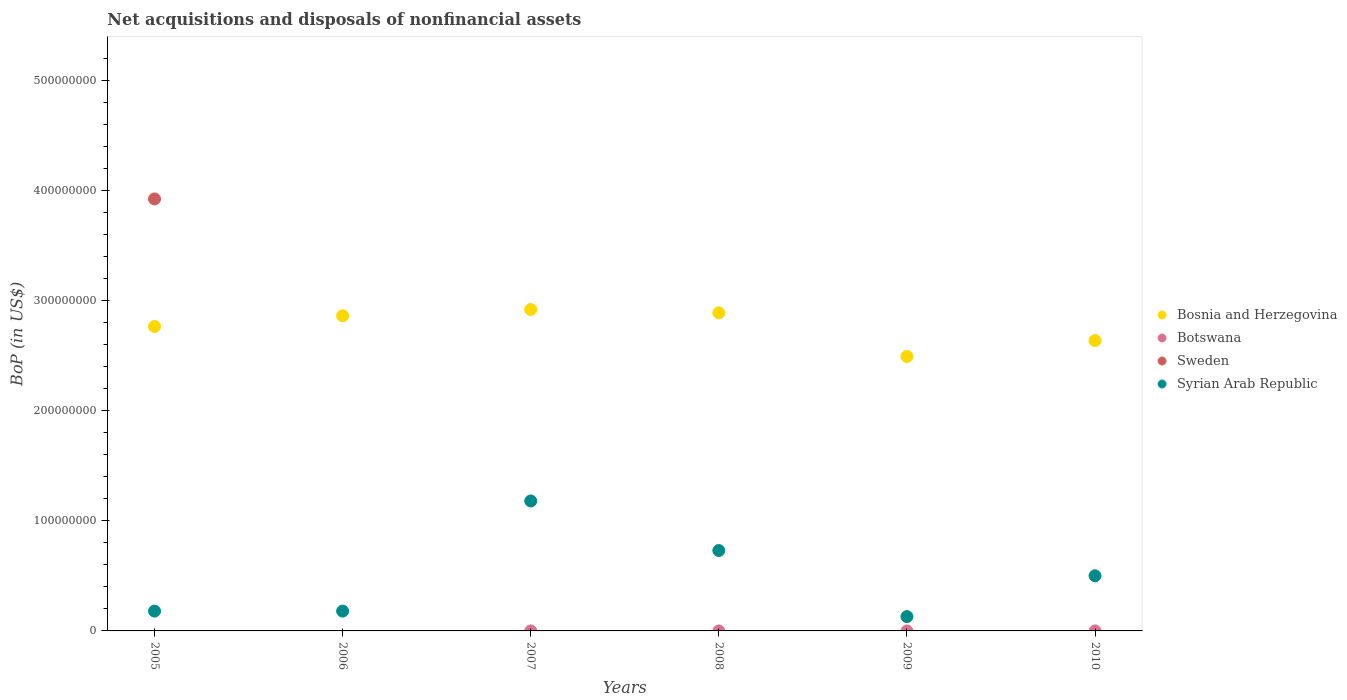How many different coloured dotlines are there?
Keep it short and to the point. 3. Across all years, what is the maximum Balance of Payments in Bosnia and Herzegovina?
Your response must be concise. 2.92e+08. In which year was the Balance of Payments in Syrian Arab Republic maximum?
Keep it short and to the point. 2007. What is the total Balance of Payments in Bosnia and Herzegovina in the graph?
Your response must be concise. 1.66e+09. What is the difference between the Balance of Payments in Syrian Arab Republic in 2009 and that in 2010?
Keep it short and to the point. -3.71e+07. What is the difference between the Balance of Payments in Botswana in 2005 and the Balance of Payments in Bosnia and Herzegovina in 2009?
Ensure brevity in your answer.  -2.49e+08. In the year 2007, what is the difference between the Balance of Payments in Syrian Arab Republic and Balance of Payments in Bosnia and Herzegovina?
Offer a very short reply. -1.74e+08. What is the ratio of the Balance of Payments in Syrian Arab Republic in 2005 to that in 2007?
Make the answer very short. 0.15. Is the Balance of Payments in Syrian Arab Republic in 2005 less than that in 2007?
Your answer should be compact. Yes. What is the difference between the highest and the second highest Balance of Payments in Bosnia and Herzegovina?
Make the answer very short. 3.07e+06. What is the difference between the highest and the lowest Balance of Payments in Sweden?
Your answer should be compact. 3.92e+08. Is the sum of the Balance of Payments in Bosnia and Herzegovina in 2008 and 2010 greater than the maximum Balance of Payments in Syrian Arab Republic across all years?
Give a very brief answer. Yes. Is it the case that in every year, the sum of the Balance of Payments in Sweden and Balance of Payments in Botswana  is greater than the Balance of Payments in Bosnia and Herzegovina?
Give a very brief answer. No. Is the Balance of Payments in Botswana strictly less than the Balance of Payments in Bosnia and Herzegovina over the years?
Make the answer very short. Yes. How many dotlines are there?
Your answer should be compact. 3. How many years are there in the graph?
Your response must be concise. 6. What is the difference between two consecutive major ticks on the Y-axis?
Keep it short and to the point. 1.00e+08. Does the graph contain any zero values?
Your answer should be compact. Yes. Does the graph contain grids?
Your response must be concise. No. What is the title of the graph?
Provide a succinct answer. Net acquisitions and disposals of nonfinancial assets. Does "Cambodia" appear as one of the legend labels in the graph?
Your answer should be very brief. No. What is the label or title of the Y-axis?
Offer a terse response. BoP (in US$). What is the BoP (in US$) of Bosnia and Herzegovina in 2005?
Your answer should be very brief. 2.76e+08. What is the BoP (in US$) of Botswana in 2005?
Keep it short and to the point. 0. What is the BoP (in US$) of Sweden in 2005?
Provide a short and direct response. 3.92e+08. What is the BoP (in US$) of Syrian Arab Republic in 2005?
Provide a short and direct response. 1.80e+07. What is the BoP (in US$) of Bosnia and Herzegovina in 2006?
Give a very brief answer. 2.86e+08. What is the BoP (in US$) of Botswana in 2006?
Offer a very short reply. 0. What is the BoP (in US$) of Syrian Arab Republic in 2006?
Ensure brevity in your answer.  1.80e+07. What is the BoP (in US$) in Bosnia and Herzegovina in 2007?
Make the answer very short. 2.92e+08. What is the BoP (in US$) in Sweden in 2007?
Give a very brief answer. 0. What is the BoP (in US$) in Syrian Arab Republic in 2007?
Your answer should be compact. 1.18e+08. What is the BoP (in US$) of Bosnia and Herzegovina in 2008?
Your answer should be very brief. 2.89e+08. What is the BoP (in US$) of Botswana in 2008?
Offer a very short reply. 0. What is the BoP (in US$) in Syrian Arab Republic in 2008?
Make the answer very short. 7.30e+07. What is the BoP (in US$) of Bosnia and Herzegovina in 2009?
Ensure brevity in your answer.  2.49e+08. What is the BoP (in US$) in Syrian Arab Republic in 2009?
Keep it short and to the point. 1.30e+07. What is the BoP (in US$) in Bosnia and Herzegovina in 2010?
Provide a succinct answer. 2.64e+08. What is the BoP (in US$) of Botswana in 2010?
Your answer should be compact. 0. What is the BoP (in US$) of Sweden in 2010?
Provide a succinct answer. 0. What is the BoP (in US$) in Syrian Arab Republic in 2010?
Make the answer very short. 5.01e+07. Across all years, what is the maximum BoP (in US$) of Bosnia and Herzegovina?
Your answer should be very brief. 2.92e+08. Across all years, what is the maximum BoP (in US$) of Sweden?
Offer a terse response. 3.92e+08. Across all years, what is the maximum BoP (in US$) in Syrian Arab Republic?
Your response must be concise. 1.18e+08. Across all years, what is the minimum BoP (in US$) in Bosnia and Herzegovina?
Offer a very short reply. 2.49e+08. Across all years, what is the minimum BoP (in US$) in Sweden?
Offer a terse response. 0. Across all years, what is the minimum BoP (in US$) in Syrian Arab Republic?
Ensure brevity in your answer.  1.30e+07. What is the total BoP (in US$) in Bosnia and Herzegovina in the graph?
Offer a terse response. 1.66e+09. What is the total BoP (in US$) of Sweden in the graph?
Your answer should be very brief. 3.92e+08. What is the total BoP (in US$) in Syrian Arab Republic in the graph?
Make the answer very short. 2.90e+08. What is the difference between the BoP (in US$) in Bosnia and Herzegovina in 2005 and that in 2006?
Keep it short and to the point. -9.77e+06. What is the difference between the BoP (in US$) in Bosnia and Herzegovina in 2005 and that in 2007?
Offer a terse response. -1.54e+07. What is the difference between the BoP (in US$) in Syrian Arab Republic in 2005 and that in 2007?
Provide a succinct answer. -1.00e+08. What is the difference between the BoP (in US$) of Bosnia and Herzegovina in 2005 and that in 2008?
Your response must be concise. -1.24e+07. What is the difference between the BoP (in US$) in Syrian Arab Republic in 2005 and that in 2008?
Provide a short and direct response. -5.50e+07. What is the difference between the BoP (in US$) in Bosnia and Herzegovina in 2005 and that in 2009?
Your answer should be very brief. 2.72e+07. What is the difference between the BoP (in US$) of Bosnia and Herzegovina in 2005 and that in 2010?
Make the answer very short. 1.28e+07. What is the difference between the BoP (in US$) in Syrian Arab Republic in 2005 and that in 2010?
Your answer should be compact. -3.21e+07. What is the difference between the BoP (in US$) in Bosnia and Herzegovina in 2006 and that in 2007?
Offer a very short reply. -5.67e+06. What is the difference between the BoP (in US$) of Syrian Arab Republic in 2006 and that in 2007?
Offer a terse response. -1.00e+08. What is the difference between the BoP (in US$) of Bosnia and Herzegovina in 2006 and that in 2008?
Keep it short and to the point. -2.60e+06. What is the difference between the BoP (in US$) of Syrian Arab Republic in 2006 and that in 2008?
Offer a very short reply. -5.50e+07. What is the difference between the BoP (in US$) in Bosnia and Herzegovina in 2006 and that in 2009?
Ensure brevity in your answer.  3.70e+07. What is the difference between the BoP (in US$) in Bosnia and Herzegovina in 2006 and that in 2010?
Your answer should be very brief. 2.25e+07. What is the difference between the BoP (in US$) in Syrian Arab Republic in 2006 and that in 2010?
Your answer should be very brief. -3.21e+07. What is the difference between the BoP (in US$) in Bosnia and Herzegovina in 2007 and that in 2008?
Ensure brevity in your answer.  3.07e+06. What is the difference between the BoP (in US$) in Syrian Arab Republic in 2007 and that in 2008?
Your response must be concise. 4.50e+07. What is the difference between the BoP (in US$) of Bosnia and Herzegovina in 2007 and that in 2009?
Your response must be concise. 4.26e+07. What is the difference between the BoP (in US$) of Syrian Arab Republic in 2007 and that in 2009?
Keep it short and to the point. 1.05e+08. What is the difference between the BoP (in US$) in Bosnia and Herzegovina in 2007 and that in 2010?
Keep it short and to the point. 2.82e+07. What is the difference between the BoP (in US$) in Syrian Arab Republic in 2007 and that in 2010?
Your answer should be compact. 6.79e+07. What is the difference between the BoP (in US$) of Bosnia and Herzegovina in 2008 and that in 2009?
Keep it short and to the point. 3.96e+07. What is the difference between the BoP (in US$) of Syrian Arab Republic in 2008 and that in 2009?
Offer a terse response. 6.00e+07. What is the difference between the BoP (in US$) in Bosnia and Herzegovina in 2008 and that in 2010?
Your answer should be very brief. 2.51e+07. What is the difference between the BoP (in US$) in Syrian Arab Republic in 2008 and that in 2010?
Your answer should be compact. 2.29e+07. What is the difference between the BoP (in US$) of Bosnia and Herzegovina in 2009 and that in 2010?
Your answer should be very brief. -1.44e+07. What is the difference between the BoP (in US$) in Syrian Arab Republic in 2009 and that in 2010?
Provide a succinct answer. -3.71e+07. What is the difference between the BoP (in US$) of Bosnia and Herzegovina in 2005 and the BoP (in US$) of Syrian Arab Republic in 2006?
Your response must be concise. 2.58e+08. What is the difference between the BoP (in US$) of Sweden in 2005 and the BoP (in US$) of Syrian Arab Republic in 2006?
Keep it short and to the point. 3.74e+08. What is the difference between the BoP (in US$) in Bosnia and Herzegovina in 2005 and the BoP (in US$) in Syrian Arab Republic in 2007?
Provide a short and direct response. 1.58e+08. What is the difference between the BoP (in US$) of Sweden in 2005 and the BoP (in US$) of Syrian Arab Republic in 2007?
Offer a very short reply. 2.74e+08. What is the difference between the BoP (in US$) in Bosnia and Herzegovina in 2005 and the BoP (in US$) in Syrian Arab Republic in 2008?
Ensure brevity in your answer.  2.03e+08. What is the difference between the BoP (in US$) in Sweden in 2005 and the BoP (in US$) in Syrian Arab Republic in 2008?
Make the answer very short. 3.19e+08. What is the difference between the BoP (in US$) in Bosnia and Herzegovina in 2005 and the BoP (in US$) in Syrian Arab Republic in 2009?
Your answer should be very brief. 2.63e+08. What is the difference between the BoP (in US$) of Sweden in 2005 and the BoP (in US$) of Syrian Arab Republic in 2009?
Provide a short and direct response. 3.79e+08. What is the difference between the BoP (in US$) in Bosnia and Herzegovina in 2005 and the BoP (in US$) in Syrian Arab Republic in 2010?
Your answer should be compact. 2.26e+08. What is the difference between the BoP (in US$) in Sweden in 2005 and the BoP (in US$) in Syrian Arab Republic in 2010?
Your answer should be compact. 3.42e+08. What is the difference between the BoP (in US$) of Bosnia and Herzegovina in 2006 and the BoP (in US$) of Syrian Arab Republic in 2007?
Provide a short and direct response. 1.68e+08. What is the difference between the BoP (in US$) in Bosnia and Herzegovina in 2006 and the BoP (in US$) in Syrian Arab Republic in 2008?
Keep it short and to the point. 2.13e+08. What is the difference between the BoP (in US$) in Bosnia and Herzegovina in 2006 and the BoP (in US$) in Syrian Arab Republic in 2009?
Make the answer very short. 2.73e+08. What is the difference between the BoP (in US$) in Bosnia and Herzegovina in 2006 and the BoP (in US$) in Syrian Arab Republic in 2010?
Ensure brevity in your answer.  2.36e+08. What is the difference between the BoP (in US$) of Bosnia and Herzegovina in 2007 and the BoP (in US$) of Syrian Arab Republic in 2008?
Offer a very short reply. 2.19e+08. What is the difference between the BoP (in US$) in Bosnia and Herzegovina in 2007 and the BoP (in US$) in Syrian Arab Republic in 2009?
Make the answer very short. 2.79e+08. What is the difference between the BoP (in US$) in Bosnia and Herzegovina in 2007 and the BoP (in US$) in Syrian Arab Republic in 2010?
Your response must be concise. 2.42e+08. What is the difference between the BoP (in US$) in Bosnia and Herzegovina in 2008 and the BoP (in US$) in Syrian Arab Republic in 2009?
Offer a very short reply. 2.76e+08. What is the difference between the BoP (in US$) of Bosnia and Herzegovina in 2008 and the BoP (in US$) of Syrian Arab Republic in 2010?
Make the answer very short. 2.39e+08. What is the difference between the BoP (in US$) of Bosnia and Herzegovina in 2009 and the BoP (in US$) of Syrian Arab Republic in 2010?
Provide a succinct answer. 1.99e+08. What is the average BoP (in US$) in Bosnia and Herzegovina per year?
Provide a succinct answer. 2.76e+08. What is the average BoP (in US$) in Sweden per year?
Provide a short and direct response. 6.54e+07. What is the average BoP (in US$) in Syrian Arab Republic per year?
Your answer should be very brief. 4.83e+07. In the year 2005, what is the difference between the BoP (in US$) in Bosnia and Herzegovina and BoP (in US$) in Sweden?
Keep it short and to the point. -1.16e+08. In the year 2005, what is the difference between the BoP (in US$) of Bosnia and Herzegovina and BoP (in US$) of Syrian Arab Republic?
Your answer should be very brief. 2.58e+08. In the year 2005, what is the difference between the BoP (in US$) in Sweden and BoP (in US$) in Syrian Arab Republic?
Your answer should be compact. 3.74e+08. In the year 2006, what is the difference between the BoP (in US$) in Bosnia and Herzegovina and BoP (in US$) in Syrian Arab Republic?
Make the answer very short. 2.68e+08. In the year 2007, what is the difference between the BoP (in US$) in Bosnia and Herzegovina and BoP (in US$) in Syrian Arab Republic?
Offer a terse response. 1.74e+08. In the year 2008, what is the difference between the BoP (in US$) in Bosnia and Herzegovina and BoP (in US$) in Syrian Arab Republic?
Your response must be concise. 2.16e+08. In the year 2009, what is the difference between the BoP (in US$) in Bosnia and Herzegovina and BoP (in US$) in Syrian Arab Republic?
Offer a terse response. 2.36e+08. In the year 2010, what is the difference between the BoP (in US$) of Bosnia and Herzegovina and BoP (in US$) of Syrian Arab Republic?
Make the answer very short. 2.14e+08. What is the ratio of the BoP (in US$) in Bosnia and Herzegovina in 2005 to that in 2006?
Give a very brief answer. 0.97. What is the ratio of the BoP (in US$) in Bosnia and Herzegovina in 2005 to that in 2007?
Offer a very short reply. 0.95. What is the ratio of the BoP (in US$) in Syrian Arab Republic in 2005 to that in 2007?
Provide a succinct answer. 0.15. What is the ratio of the BoP (in US$) of Bosnia and Herzegovina in 2005 to that in 2008?
Your response must be concise. 0.96. What is the ratio of the BoP (in US$) in Syrian Arab Republic in 2005 to that in 2008?
Make the answer very short. 0.25. What is the ratio of the BoP (in US$) of Bosnia and Herzegovina in 2005 to that in 2009?
Provide a short and direct response. 1.11. What is the ratio of the BoP (in US$) of Syrian Arab Republic in 2005 to that in 2009?
Give a very brief answer. 1.38. What is the ratio of the BoP (in US$) in Bosnia and Herzegovina in 2005 to that in 2010?
Your answer should be very brief. 1.05. What is the ratio of the BoP (in US$) in Syrian Arab Republic in 2005 to that in 2010?
Give a very brief answer. 0.36. What is the ratio of the BoP (in US$) in Bosnia and Herzegovina in 2006 to that in 2007?
Provide a succinct answer. 0.98. What is the ratio of the BoP (in US$) of Syrian Arab Republic in 2006 to that in 2007?
Offer a terse response. 0.15. What is the ratio of the BoP (in US$) in Syrian Arab Republic in 2006 to that in 2008?
Ensure brevity in your answer.  0.25. What is the ratio of the BoP (in US$) of Bosnia and Herzegovina in 2006 to that in 2009?
Your answer should be very brief. 1.15. What is the ratio of the BoP (in US$) of Syrian Arab Republic in 2006 to that in 2009?
Make the answer very short. 1.38. What is the ratio of the BoP (in US$) of Bosnia and Herzegovina in 2006 to that in 2010?
Provide a succinct answer. 1.09. What is the ratio of the BoP (in US$) in Syrian Arab Republic in 2006 to that in 2010?
Provide a short and direct response. 0.36. What is the ratio of the BoP (in US$) of Bosnia and Herzegovina in 2007 to that in 2008?
Provide a succinct answer. 1.01. What is the ratio of the BoP (in US$) in Syrian Arab Republic in 2007 to that in 2008?
Ensure brevity in your answer.  1.62. What is the ratio of the BoP (in US$) of Bosnia and Herzegovina in 2007 to that in 2009?
Provide a short and direct response. 1.17. What is the ratio of the BoP (in US$) in Syrian Arab Republic in 2007 to that in 2009?
Ensure brevity in your answer.  9.08. What is the ratio of the BoP (in US$) of Bosnia and Herzegovina in 2007 to that in 2010?
Provide a succinct answer. 1.11. What is the ratio of the BoP (in US$) in Syrian Arab Republic in 2007 to that in 2010?
Provide a short and direct response. 2.36. What is the ratio of the BoP (in US$) in Bosnia and Herzegovina in 2008 to that in 2009?
Offer a terse response. 1.16. What is the ratio of the BoP (in US$) of Syrian Arab Republic in 2008 to that in 2009?
Your response must be concise. 5.62. What is the ratio of the BoP (in US$) in Bosnia and Herzegovina in 2008 to that in 2010?
Keep it short and to the point. 1.1. What is the ratio of the BoP (in US$) of Syrian Arab Republic in 2008 to that in 2010?
Offer a terse response. 1.46. What is the ratio of the BoP (in US$) of Bosnia and Herzegovina in 2009 to that in 2010?
Your answer should be compact. 0.95. What is the ratio of the BoP (in US$) in Syrian Arab Republic in 2009 to that in 2010?
Your response must be concise. 0.26. What is the difference between the highest and the second highest BoP (in US$) of Bosnia and Herzegovina?
Your answer should be compact. 3.07e+06. What is the difference between the highest and the second highest BoP (in US$) in Syrian Arab Republic?
Offer a very short reply. 4.50e+07. What is the difference between the highest and the lowest BoP (in US$) in Bosnia and Herzegovina?
Offer a very short reply. 4.26e+07. What is the difference between the highest and the lowest BoP (in US$) of Sweden?
Keep it short and to the point. 3.92e+08. What is the difference between the highest and the lowest BoP (in US$) in Syrian Arab Republic?
Give a very brief answer. 1.05e+08. 